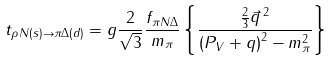Convert formula to latex. <formula><loc_0><loc_0><loc_500><loc_500>t _ { \rho N ( s ) \rightarrow \pi \Delta ( d ) } = g \frac { 2 } { \sqrt { 3 } } \frac { f _ { \pi N \Delta } } { m _ { \pi } } \left \{ \frac { \frac { 2 } { 3 } \vec { q } \, ^ { 2 } } { \left ( P _ { V } + q \right ) ^ { 2 } - m _ { \pi } ^ { 2 } } \right \}</formula> 